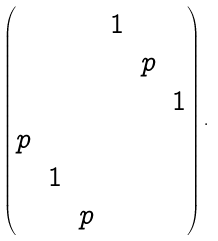Convert formula to latex. <formula><loc_0><loc_0><loc_500><loc_500>\begin{pmatrix} & & & 1 & & \\ & & & & p & \\ & & & & & 1 \\ p & & & & & \\ & 1 & & & & \\ & & p & & & \\ \end{pmatrix} .</formula> 